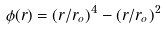<formula> <loc_0><loc_0><loc_500><loc_500>\phi ( r ) = ( r / r _ { o } ) ^ { 4 } - ( r / r _ { o } ) ^ { 2 }</formula> 